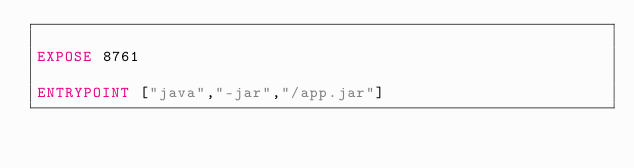Convert code to text. <code><loc_0><loc_0><loc_500><loc_500><_Dockerfile_>
EXPOSE 8761

ENTRYPOINT ["java","-jar","/app.jar"]</code> 